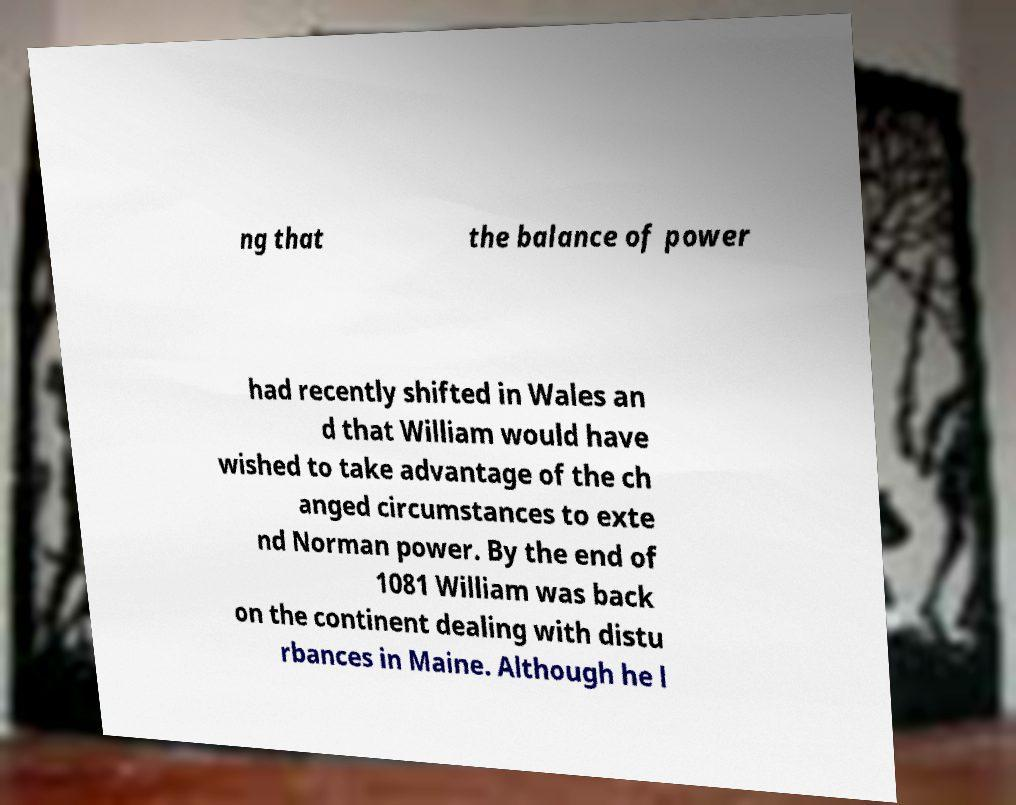Could you extract and type out the text from this image? ng that the balance of power had recently shifted in Wales an d that William would have wished to take advantage of the ch anged circumstances to exte nd Norman power. By the end of 1081 William was back on the continent dealing with distu rbances in Maine. Although he l 